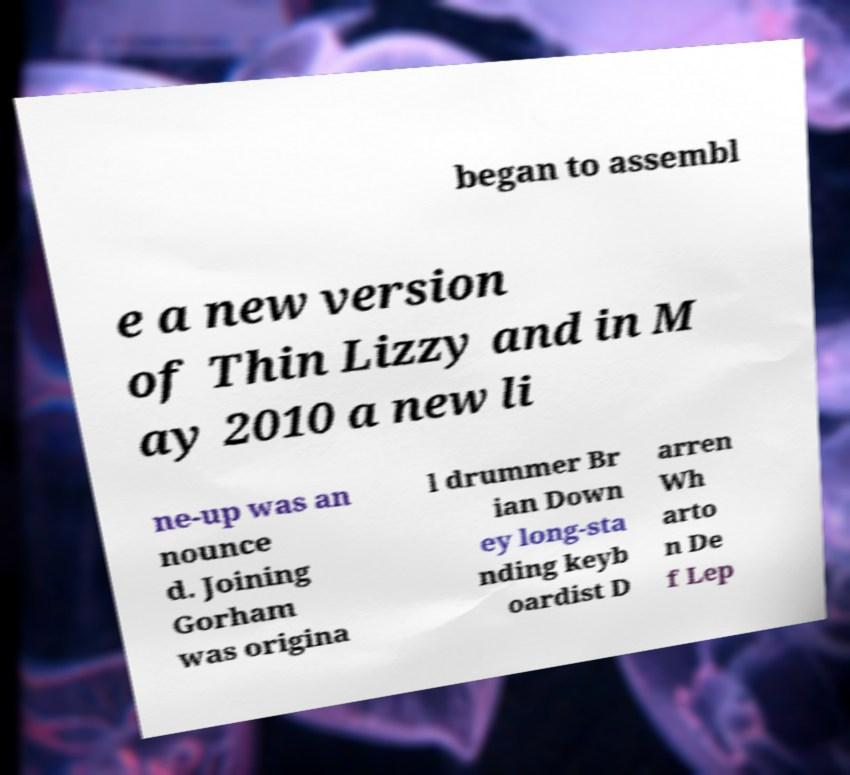Can you accurately transcribe the text from the provided image for me? began to assembl e a new version of Thin Lizzy and in M ay 2010 a new li ne-up was an nounce d. Joining Gorham was origina l drummer Br ian Down ey long-sta nding keyb oardist D arren Wh arto n De f Lep 